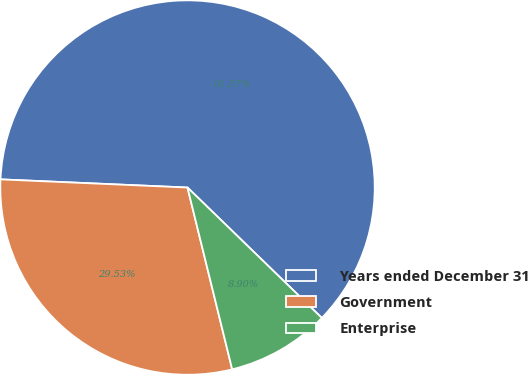<chart> <loc_0><loc_0><loc_500><loc_500><pie_chart><fcel>Years ended December 31<fcel>Government<fcel>Enterprise<nl><fcel>61.57%<fcel>29.53%<fcel>8.9%<nl></chart> 